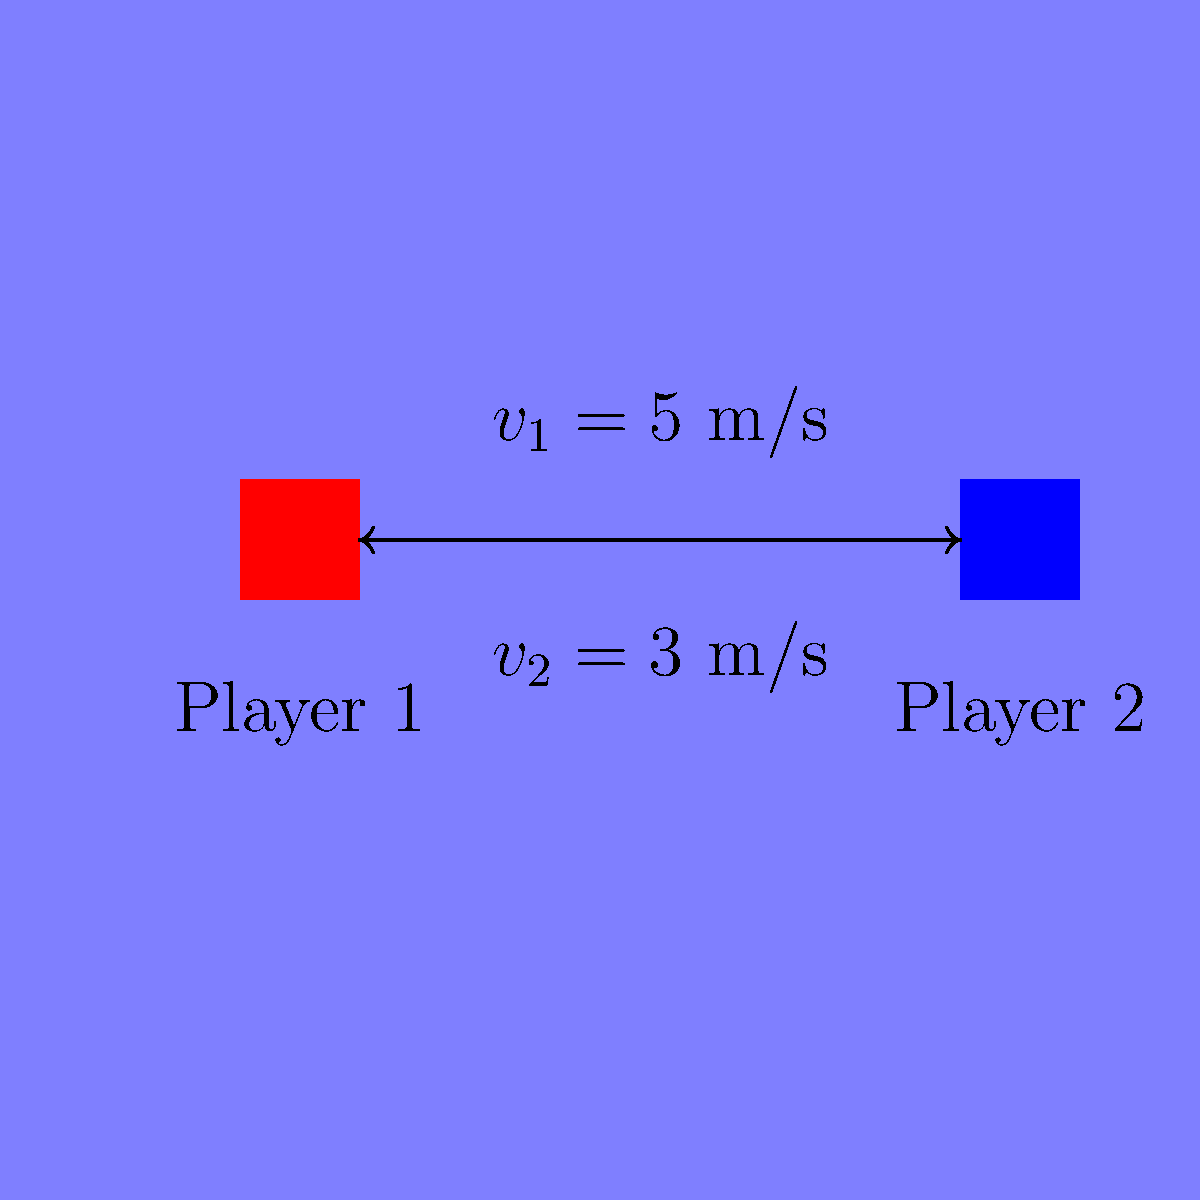During an intense Ässät game, two players collide head-on. Player 1, weighing 90 kg, is skating at 5 m/s, while Player 2, weighing 100 kg, is moving at 3 m/s in the opposite direction. Assuming a perfectly inelastic collision, what is the velocity of the players immediately after the collision? To solve this problem, we'll use the principle of conservation of momentum, which applies even in inelastic collisions. Let's approach this step-by-step:

1) First, let's define our variables:
   $m_1 = 90$ kg (mass of Player 1)
   $v_1 = 5$ m/s (initial velocity of Player 1)
   $m_2 = 100$ kg (mass of Player 2)
   $v_2 = -3$ m/s (initial velocity of Player 2, negative because it's in the opposite direction)
   $v_f$ = final velocity of both players after collision

2) The conservation of momentum states that the total momentum before the collision equals the total momentum after the collision:

   $m_1v_1 + m_2v_2 = (m_1 + m_2)v_f$

3) Let's substitute our known values:

   $90(5) + 100(-3) = (90 + 100)v_f$

4) Simplify the left side:

   $450 - 300 = 190v_f$

5) Further simplification:

   $150 = 190v_f$

6) Solve for $v_f$:

   $v_f = \frac{150}{190} \approx 0.789$ m/s

Therefore, immediately after the collision, both players will be moving together at approximately 0.789 m/s in the direction Player 1 was originally moving.
Answer: 0.789 m/s 